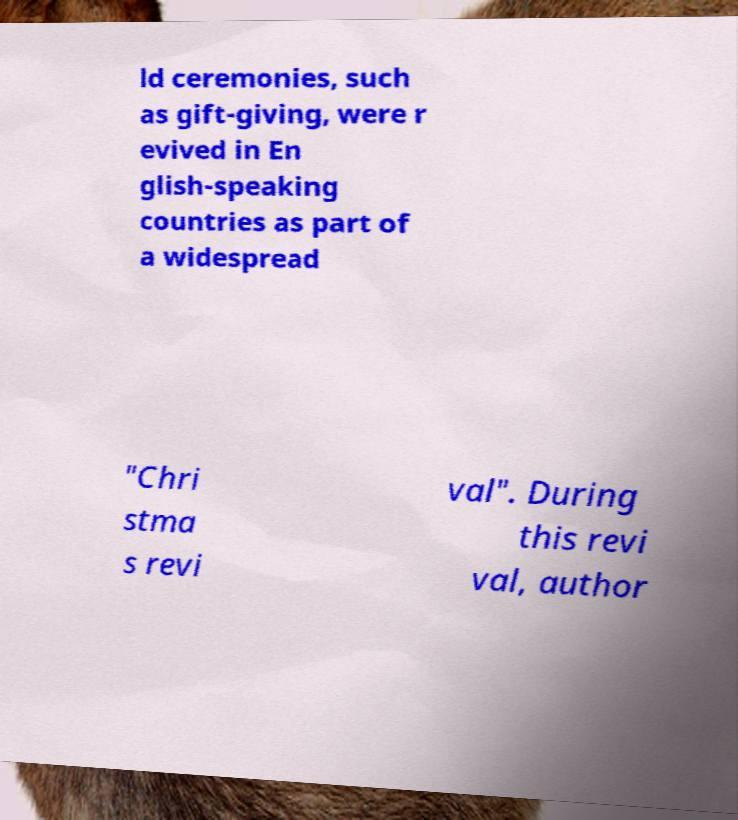There's text embedded in this image that I need extracted. Can you transcribe it verbatim? ld ceremonies, such as gift-giving, were r evived in En glish-speaking countries as part of a widespread "Chri stma s revi val". During this revi val, author 